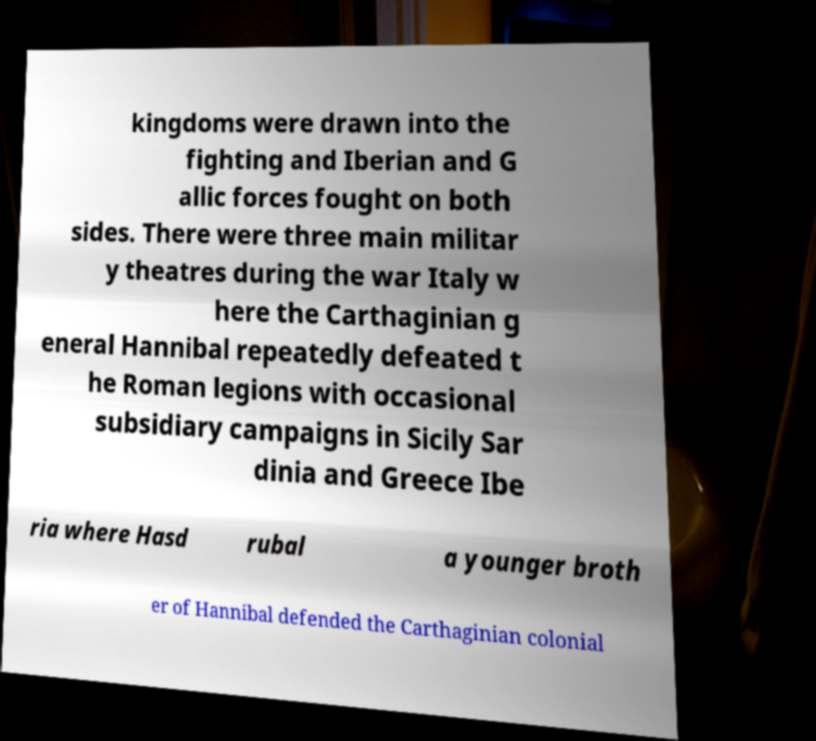Could you assist in decoding the text presented in this image and type it out clearly? kingdoms were drawn into the fighting and Iberian and G allic forces fought on both sides. There were three main militar y theatres during the war Italy w here the Carthaginian g eneral Hannibal repeatedly defeated t he Roman legions with occasional subsidiary campaigns in Sicily Sar dinia and Greece Ibe ria where Hasd rubal a younger broth er of Hannibal defended the Carthaginian colonial 